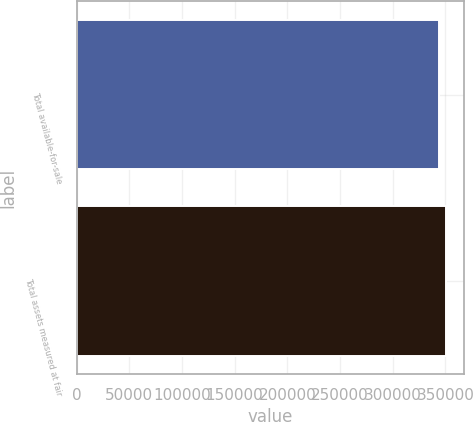<chart> <loc_0><loc_0><loc_500><loc_500><bar_chart><fcel>Total available-for-sale<fcel>Total assets measured at fair<nl><fcel>343981<fcel>350449<nl></chart> 